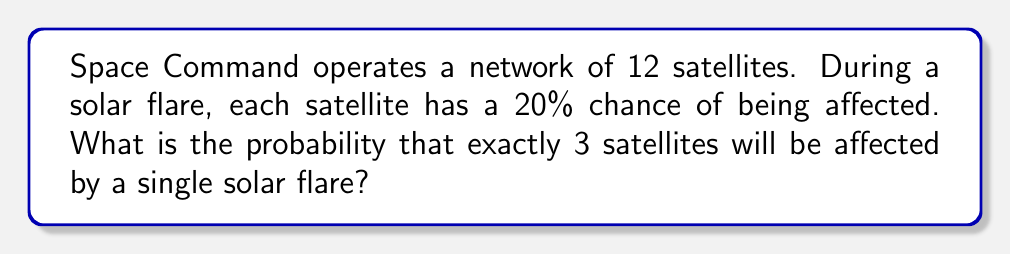Could you help me with this problem? To solve this problem, we'll use the binomial probability formula:

$$ P(X = k) = \binom{n}{k} p^k (1-p)^{n-k} $$

Where:
- $n$ is the total number of satellites (12)
- $k$ is the number of affected satellites (3)
- $p$ is the probability of a single satellite being affected (0.20)

Step 1: Calculate the binomial coefficient $\binom{n}{k}$
$$ \binom{12}{3} = \frac{12!}{3!(12-3)!} = \frac{12!}{3!9!} = 220 $$

Step 2: Calculate $p^k$
$$ 0.20^3 = 0.008 $$

Step 3: Calculate $(1-p)^{n-k}$
$$ (1-0.20)^{12-3} = 0.80^9 \approx 0.1342 $$

Step 4: Multiply all components
$$ P(X = 3) = 220 \times 0.008 \times 0.1342 \approx 0.2361 $$

Therefore, the probability of exactly 3 satellites being affected is approximately 0.2361 or 23.61%.
Answer: $0.2361$ or $23.61\%$ 